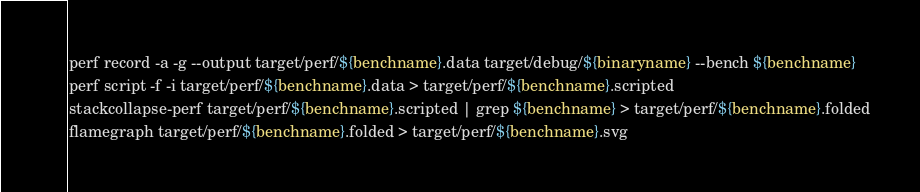<code> <loc_0><loc_0><loc_500><loc_500><_Bash_>perf record -a -g --output target/perf/${benchname}.data target/debug/${binaryname} --bench ${benchname}
perf script -f -i target/perf/${benchname}.data > target/perf/${benchname}.scripted
stackcollapse-perf target/perf/${benchname}.scripted | grep ${benchname} > target/perf/${benchname}.folded
flamegraph target/perf/${benchname}.folded > target/perf/${benchname}.svg
</code> 